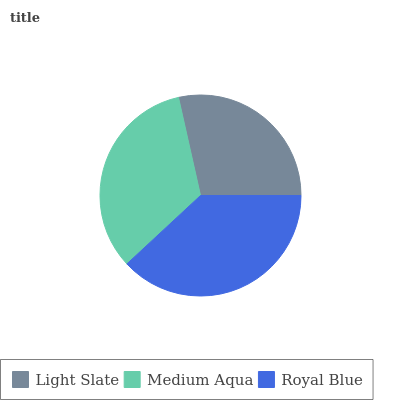Is Light Slate the minimum?
Answer yes or no. Yes. Is Royal Blue the maximum?
Answer yes or no. Yes. Is Medium Aqua the minimum?
Answer yes or no. No. Is Medium Aqua the maximum?
Answer yes or no. No. Is Medium Aqua greater than Light Slate?
Answer yes or no. Yes. Is Light Slate less than Medium Aqua?
Answer yes or no. Yes. Is Light Slate greater than Medium Aqua?
Answer yes or no. No. Is Medium Aqua less than Light Slate?
Answer yes or no. No. Is Medium Aqua the high median?
Answer yes or no. Yes. Is Medium Aqua the low median?
Answer yes or no. Yes. Is Light Slate the high median?
Answer yes or no. No. Is Light Slate the low median?
Answer yes or no. No. 